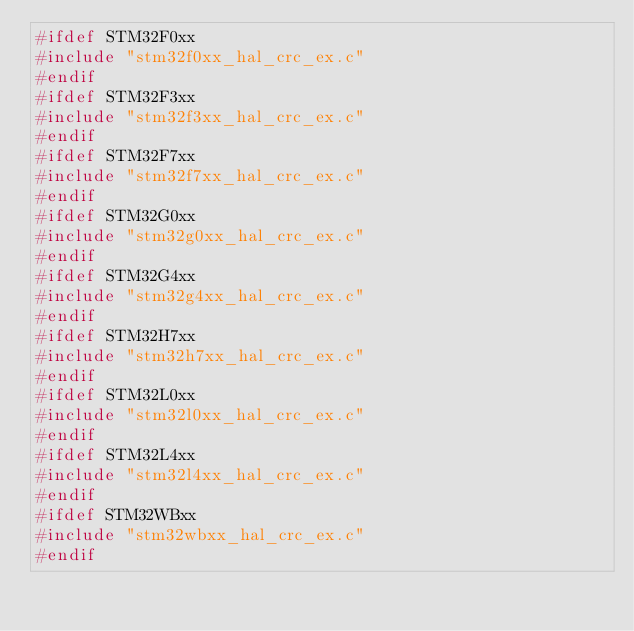Convert code to text. <code><loc_0><loc_0><loc_500><loc_500><_C_>#ifdef STM32F0xx
#include "stm32f0xx_hal_crc_ex.c"
#endif
#ifdef STM32F3xx
#include "stm32f3xx_hal_crc_ex.c"
#endif
#ifdef STM32F7xx
#include "stm32f7xx_hal_crc_ex.c"
#endif
#ifdef STM32G0xx
#include "stm32g0xx_hal_crc_ex.c"
#endif
#ifdef STM32G4xx
#include "stm32g4xx_hal_crc_ex.c"
#endif
#ifdef STM32H7xx
#include "stm32h7xx_hal_crc_ex.c"
#endif
#ifdef STM32L0xx
#include "stm32l0xx_hal_crc_ex.c"
#endif
#ifdef STM32L4xx
#include "stm32l4xx_hal_crc_ex.c"
#endif
#ifdef STM32WBxx
#include "stm32wbxx_hal_crc_ex.c"
#endif
</code> 